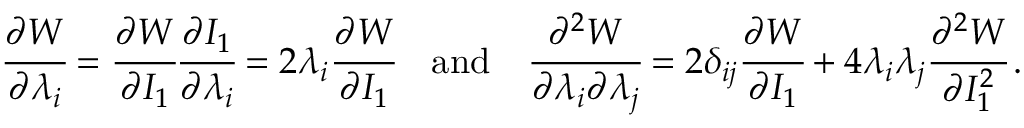<formula> <loc_0><loc_0><loc_500><loc_500>{ \cfrac { \partial W } { \partial \lambda _ { i } } } = { \cfrac { \partial W } { \partial I _ { 1 } } } { \cfrac { \partial I _ { 1 } } { \partial \lambda _ { i } } } = 2 \lambda _ { i } { \cfrac { \partial W } { \partial I _ { 1 } } } \quad a n d \quad \cfrac { \partial ^ { 2 } W } { \partial \lambda _ { i } \partial \lambda _ { j } } = 2 \delta _ { i j } { \cfrac { \partial W } { \partial I _ { 1 } } } + 4 \lambda _ { i } \lambda _ { j } { \cfrac { \partial ^ { 2 } W } { \partial I _ { 1 } ^ { 2 } } } \, .</formula> 